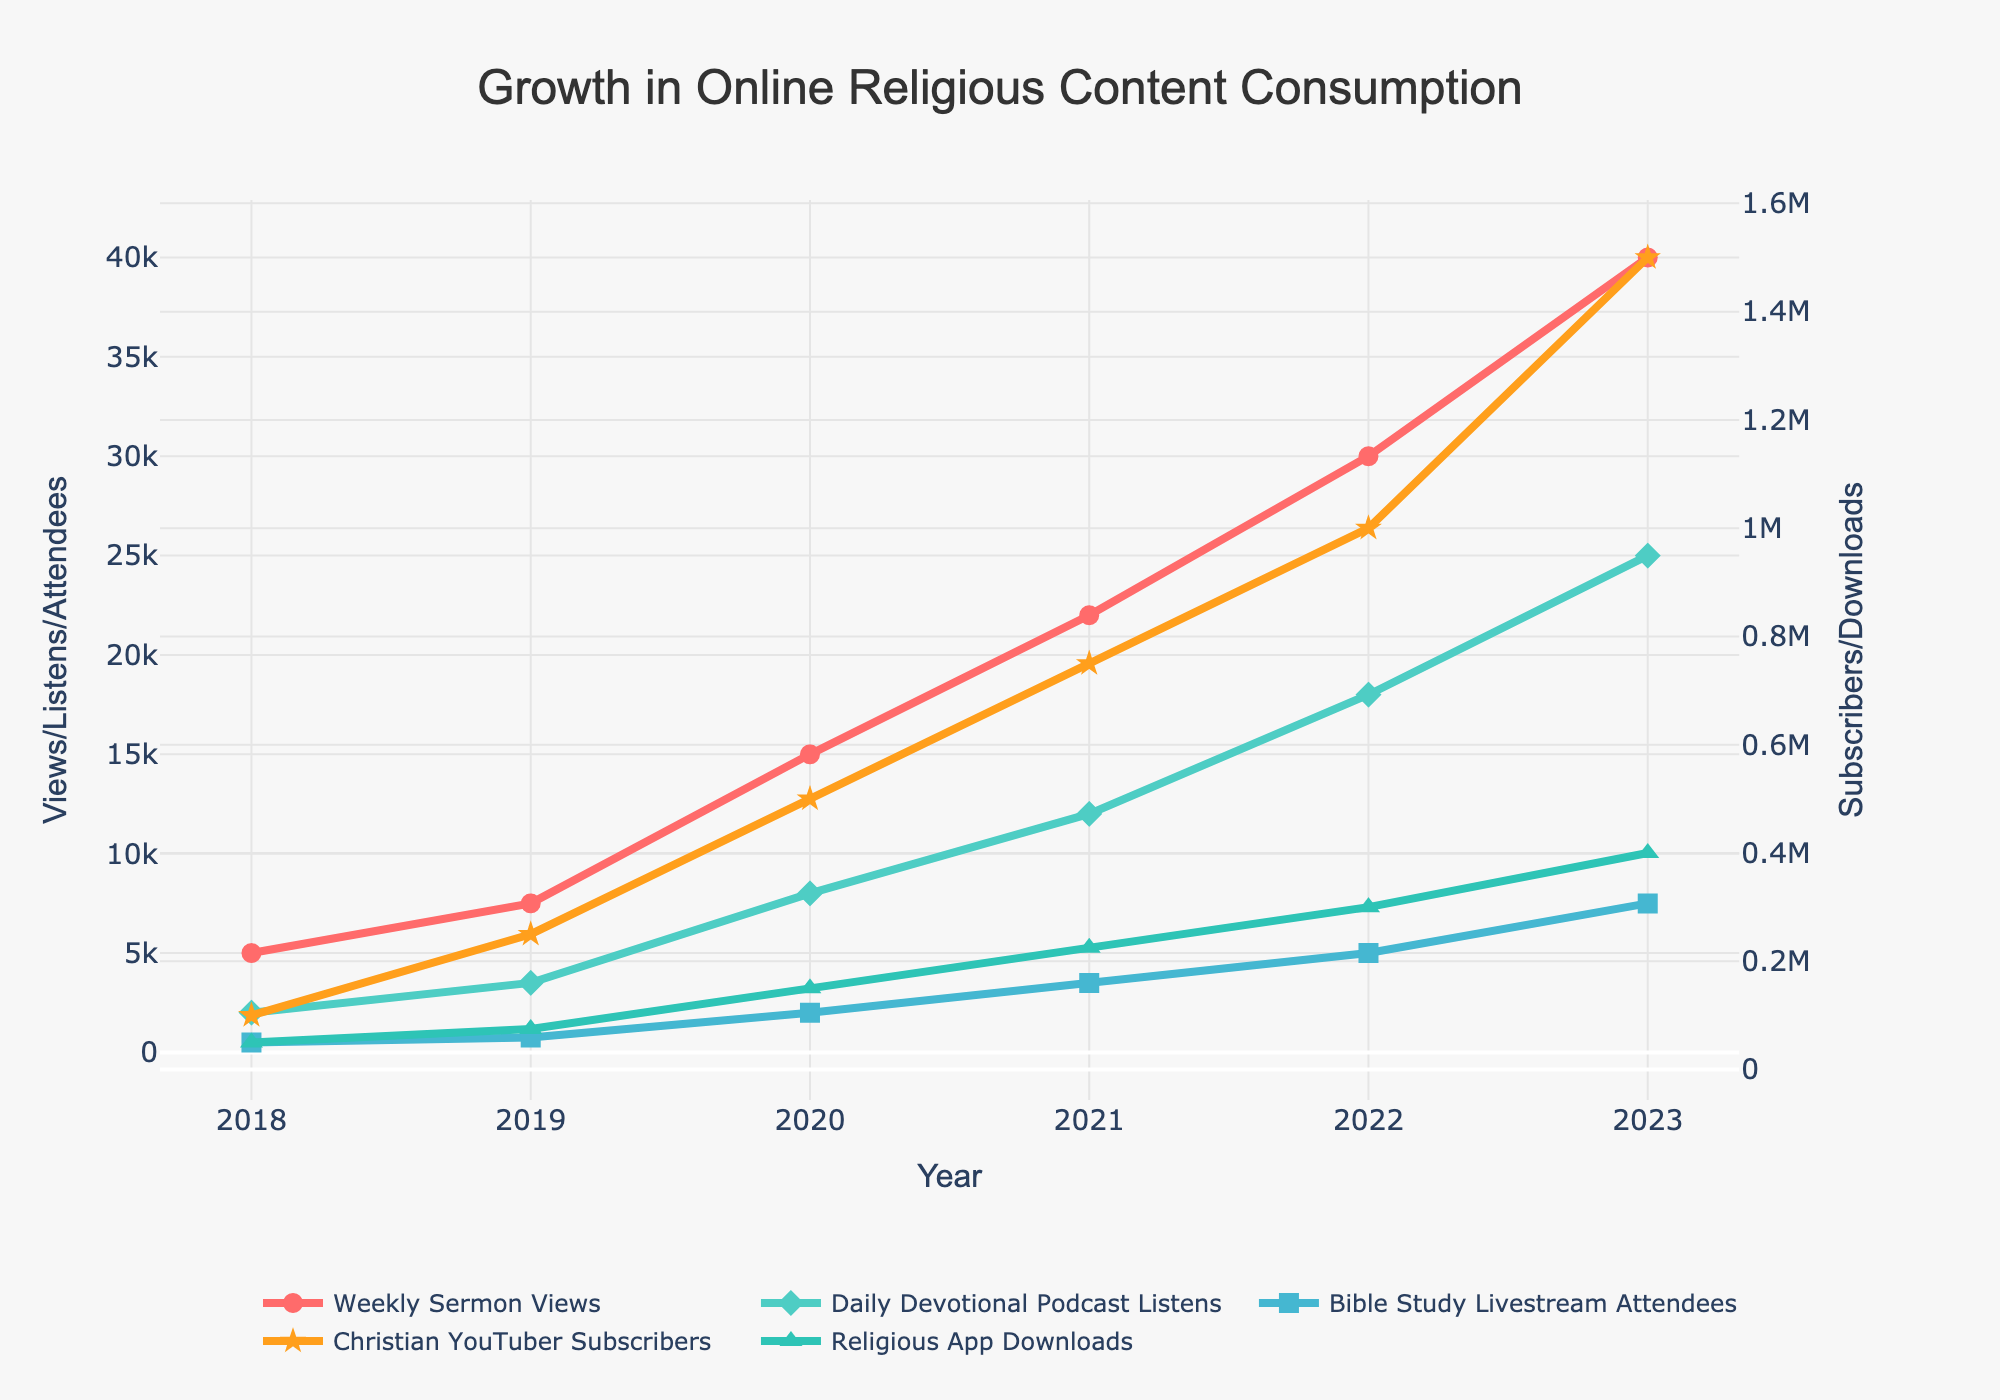What's the total number of Weekly Sermon Views and Daily Devotional Podcast Listens in 2020? First, note the numbers for Weekly Sermon Views (15,000) and Daily Devotional Podcast Listens (8,000) in 2020. Add these together: 15,000 + 8,000 = 23,000.
Answer: 23,000 Which year saw the highest increase in Religious App Downloads compared to the previous year? Calculate the difference in Religious App Downloads year by year: 2018-2019: 75,000 - 50,000 = 25,000,  2019-2020: 150,000 - 75,000 = 75,000, 2020-2021: 225,000 - 150,000 = 75,000, 2021-2022: 300,000 - 225,000 = 75,000, 2022-2023: 400,000 - 300,000 = 100,000. The highest increase occurred from 2022 to 2023.
Answer: 2022 to 2023 By how many subscribers did Christian YouTuber Subscribers exceed Weekly Sermon Views in 2023? First, note the numbers for Christian YouTuber Subscribers (1,500,000) and Weekly Sermon Views (40,000) in 2023. Subtract Weekly Sermon Views from Christian YouTuber Subscribers: 1,500,000 - 40,000 = 1,460,000.
Answer: 1,460,000 Which category's growth appears the most consistent over the years in terms of visual trend? Christian YouTuber Subscribers show the most consistent growth with a steadily increasing line each year from 2018 to 2023.
Answer: Christian YouTuber Subscribers What's the average number of Bible Study Livestream Attendees between 2019 and 2021? Note the numbers for Bible Study Livestream Attendees for 2019 (750), 2020 (2,000), and 2021 (3,500). Add these together and divide by 3: (750 + 2,000 + 3,500) / 3 = 2,083.33.
Answer: 2,083.33 Between which two consecutive years did Weekly Sermon Views experience the highest growth percentage? First, calculate the percentage growth for each year: 2018-2019: ((7,500 - 5,000) / 5,000) * 100 = 50%, 2019-2020: ((15,000 - 7,500) / 7,500) * 100 = 100%, 2020-2021: ((22,000 - 15,000) / 15,000) * 100 = 46.67%, 2021-2022: ((30,000 - 22,000) / 22,000) * 100 = 36.36%, 2022-2023: ((40,000 - 30,000) / 30,000) * 100 = 33.33%. The highest growth percentage is from 2019 to 2020.
Answer: 2019 to 2020 